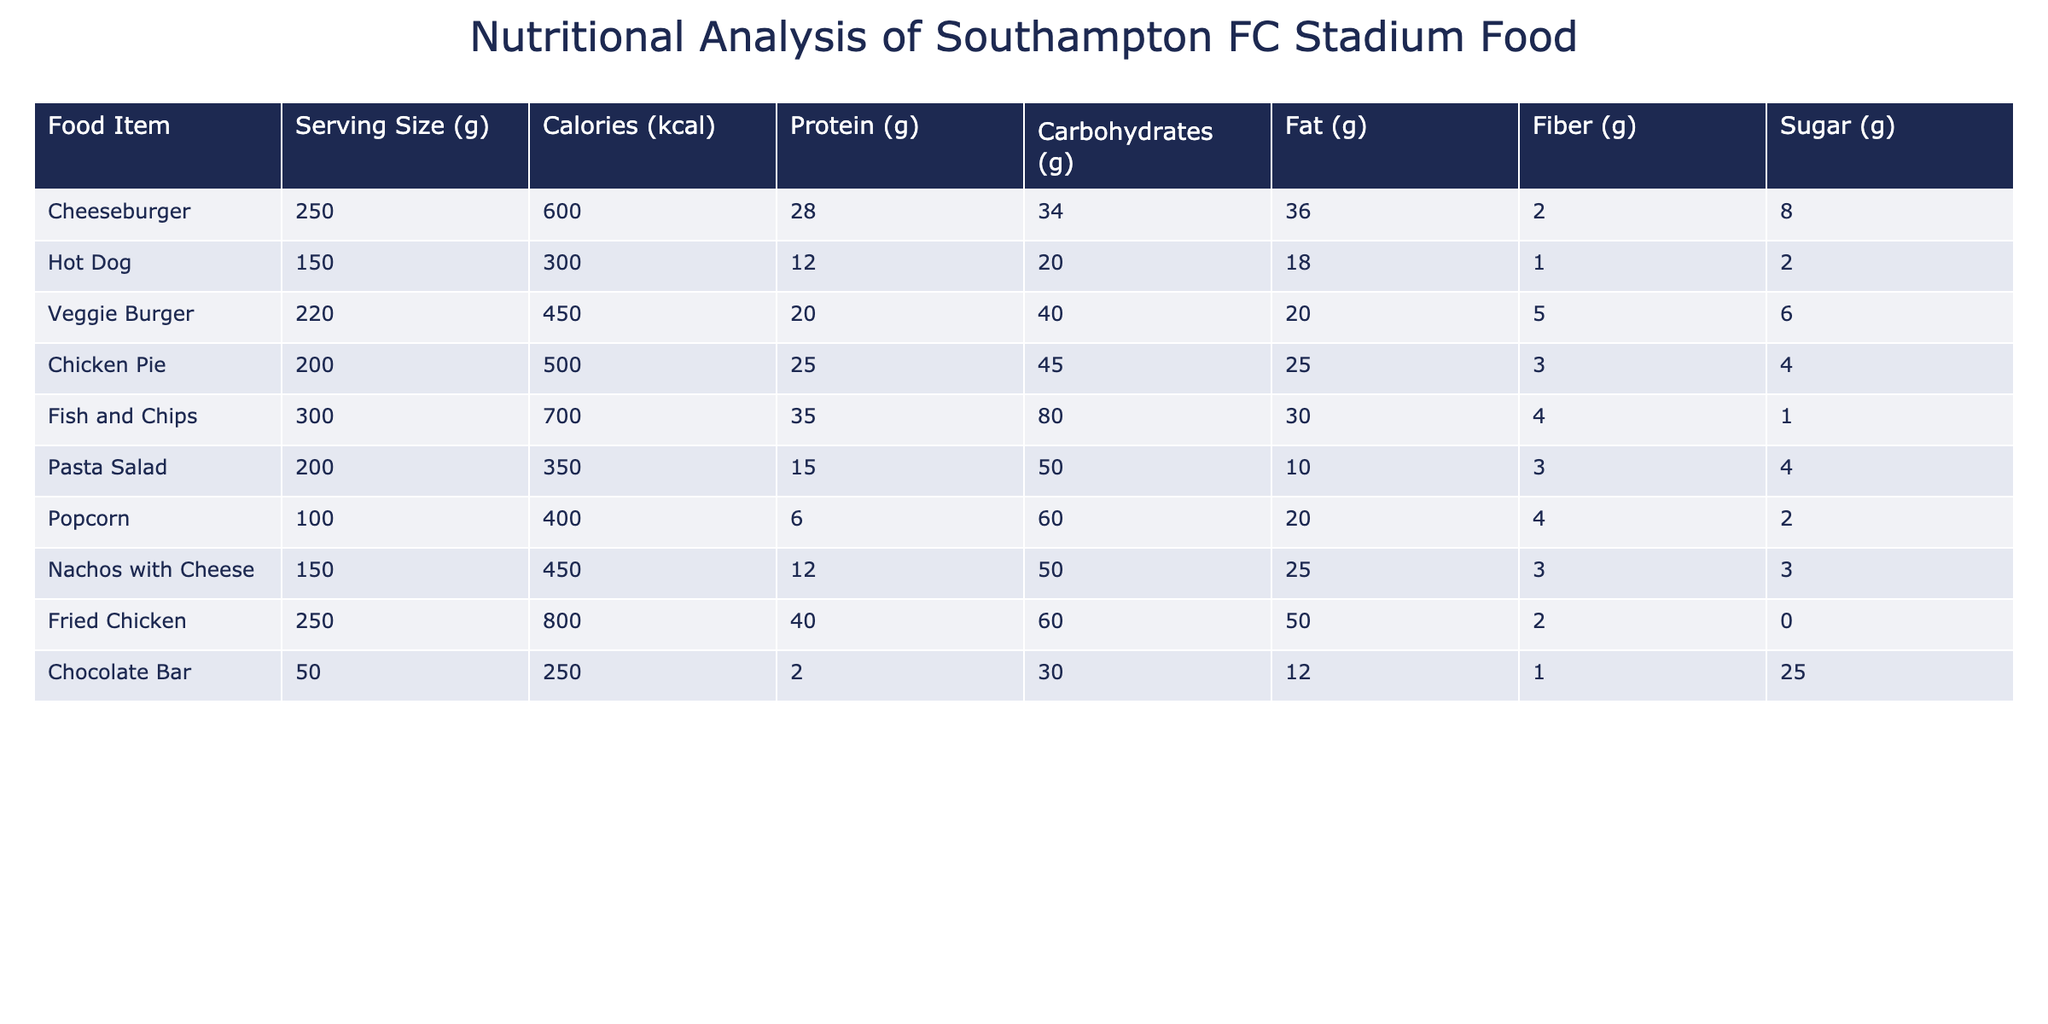What is the calorie content of the Veggie Burger? The table shows the Veggie Burger has 450 calories listed in the Calories column next to the item.
Answer: 450 Which food item has the highest protein content? By checking the Protein column, we see Fried Chicken has the highest protein at 40 grams.
Answer: Fried Chicken What is the average fat content of all the food items? First, we sum the fat content of all items: 36 + 18 + 20 + 25 + 30 + 10 + 20 + 25 + 50 + 12 =  256 grams. There are 10 items, so the average is 256 / 10 = 25.6 grams.
Answer: 25.6 Does the Popcorn have more calories than the Hot Dog? Looking at the Calories column, Popcorn has 400 kcal, while Hot Dog has 300 kcal. Since 400 is greater than 300, Popcorn does have more calories.
Answer: Yes If I want to limit my sugar intake, which food item should I avoid? The highest sugar content in the table is in the Chocolate Bar with 25 grams, making it the food item to avoid for limiting sugar intake.
Answer: Chocolate Bar What is the total carbohydrate content of Fish and Chips and Fried Chicken? Combining the Carbohydrates from Fish and Chips (80 grams) and Fried Chicken (60 grams), we have 80 + 60 = 140 grams.
Answer: 140 Is the serving size of the Chicken Pie larger than the Nachos with Cheese? Chicken Pie's serving size is 200 grams, while Nachos with Cheese is 150 grams. Since 200 is greater than 150, the Chicken Pie has a larger serving size.
Answer: Yes How many food items have more than 500 calories? Checking the Calories column, we see Fish and Chips (700), Fried Chicken (800), and Cheeseburger (600) all exceed 500 calories. Thus, there are 3 items that meet this criterion.
Answer: 3 Which food item provides the least amount of fiber? Referring to the Fiber column, Popcorn and Cheeseburger each have 2 grams, which is the lowest compared to others.
Answer: Popcorn and Cheeseburger 